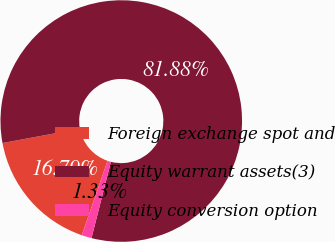<chart> <loc_0><loc_0><loc_500><loc_500><pie_chart><fcel>Foreign exchange spot and<fcel>Equity warrant assets(3)<fcel>Equity conversion option<nl><fcel>16.79%<fcel>81.88%<fcel>1.33%<nl></chart> 